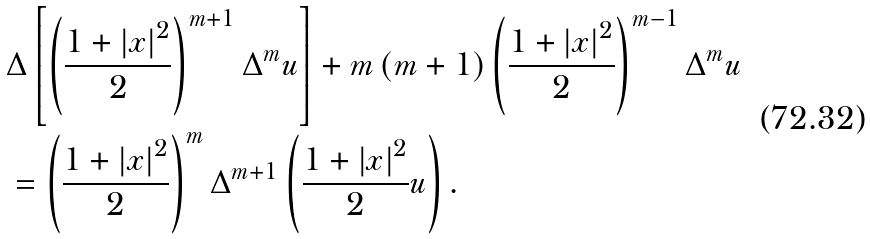Convert formula to latex. <formula><loc_0><loc_0><loc_500><loc_500>& \Delta \left [ \left ( \frac { 1 + \left | x \right | ^ { 2 } } { 2 } \right ) ^ { m + 1 } \Delta ^ { m } u \right ] + m \left ( m + 1 \right ) \left ( \frac { 1 + \left | x \right | ^ { 2 } } { 2 } \right ) ^ { m - 1 } \Delta ^ { m } u \\ & = \left ( \frac { 1 + \left | x \right | ^ { 2 } } { 2 } \right ) ^ { m } \Delta ^ { m + 1 } \left ( \frac { 1 + \left | x \right | ^ { 2 } } { 2 } u \right ) .</formula> 